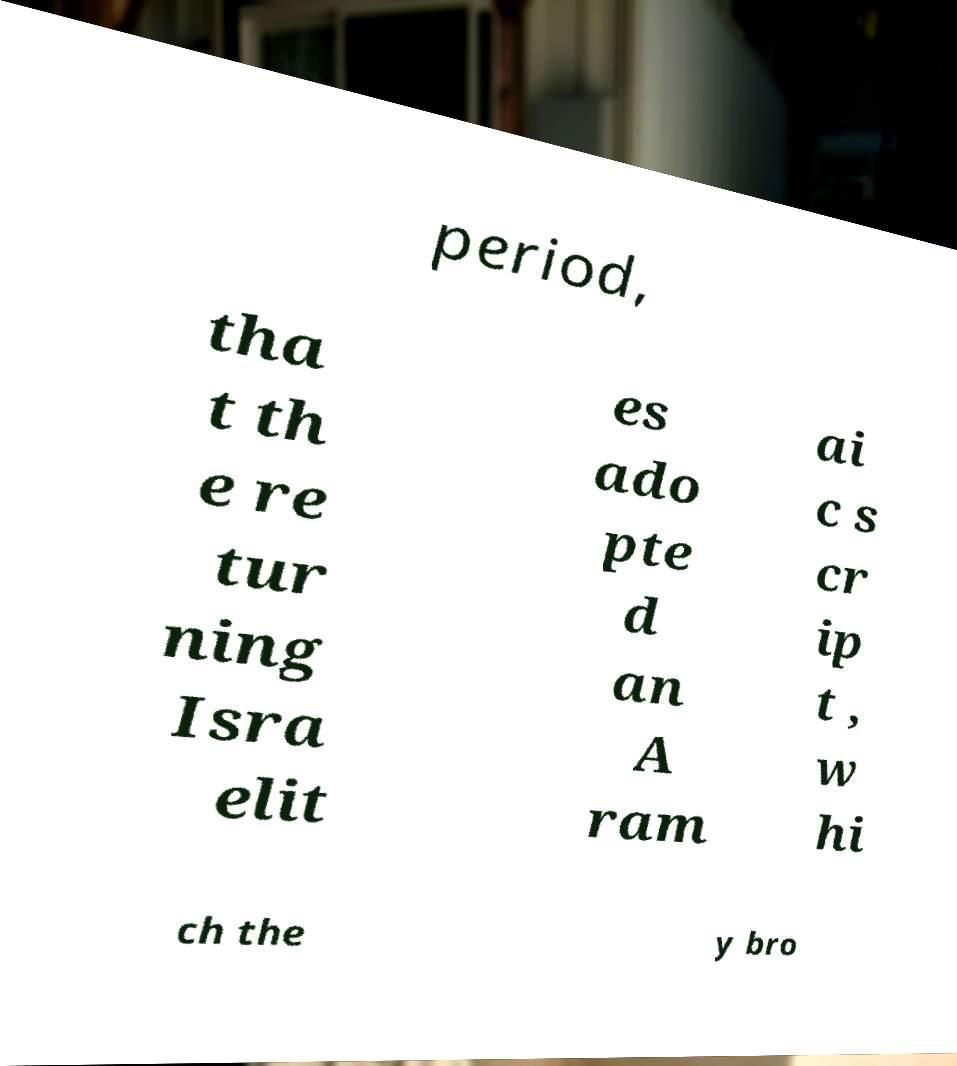Please identify and transcribe the text found in this image. period, tha t th e re tur ning Isra elit es ado pte d an A ram ai c s cr ip t , w hi ch the y bro 